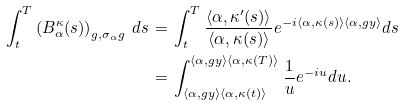<formula> <loc_0><loc_0><loc_500><loc_500>\int _ { t } ^ { T } \left ( B _ { \alpha } ^ { \kappa } ( s ) \right ) _ { g , \sigma _ { \alpha } g } \, d s \, = & \, \int _ { t } ^ { T } \frac { \langle \alpha , \kappa ^ { \prime } ( s ) \rangle } { \langle \alpha , \kappa ( s ) \rangle } e ^ { - i \langle \alpha , \kappa ( s ) \rangle \langle \alpha , g y \rangle } d s \\ = & \, \int _ { \langle \alpha , g y \rangle \langle \alpha , \kappa ( t ) \rangle } ^ { \langle \alpha , g y \rangle \langle \alpha , \kappa ( T ) \rangle } \frac { 1 } { u } e ^ { - i u } d u .</formula> 